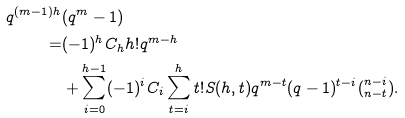<formula> <loc_0><loc_0><loc_500><loc_500>q ^ { ( m - 1 ) h } & ( q ^ { m } - 1 ) \\ = & ( - 1 ) ^ { h } C _ { h } h ! q ^ { m - h } \\ & + \sum _ { i = 0 } ^ { h - 1 } ( - 1 ) ^ { i } C _ { i } \sum _ { t = i } ^ { h } t ! S ( h , t ) q ^ { m - t } ( q - 1 ) ^ { t - i } ( ^ { n - i } _ { n - t } ) .</formula> 